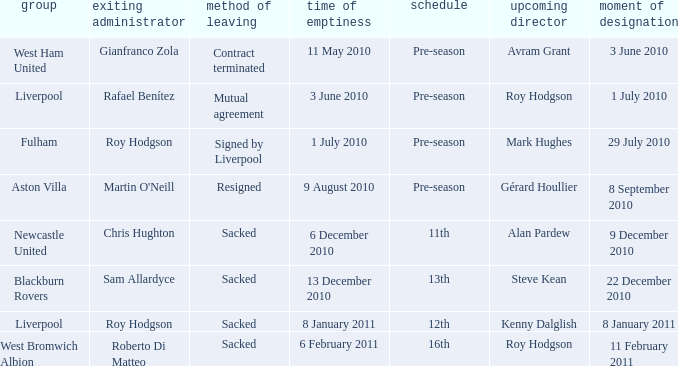What was the date of appointment for incoming manager Roy Hodgson and the team is Liverpool? 1 July 2010. 